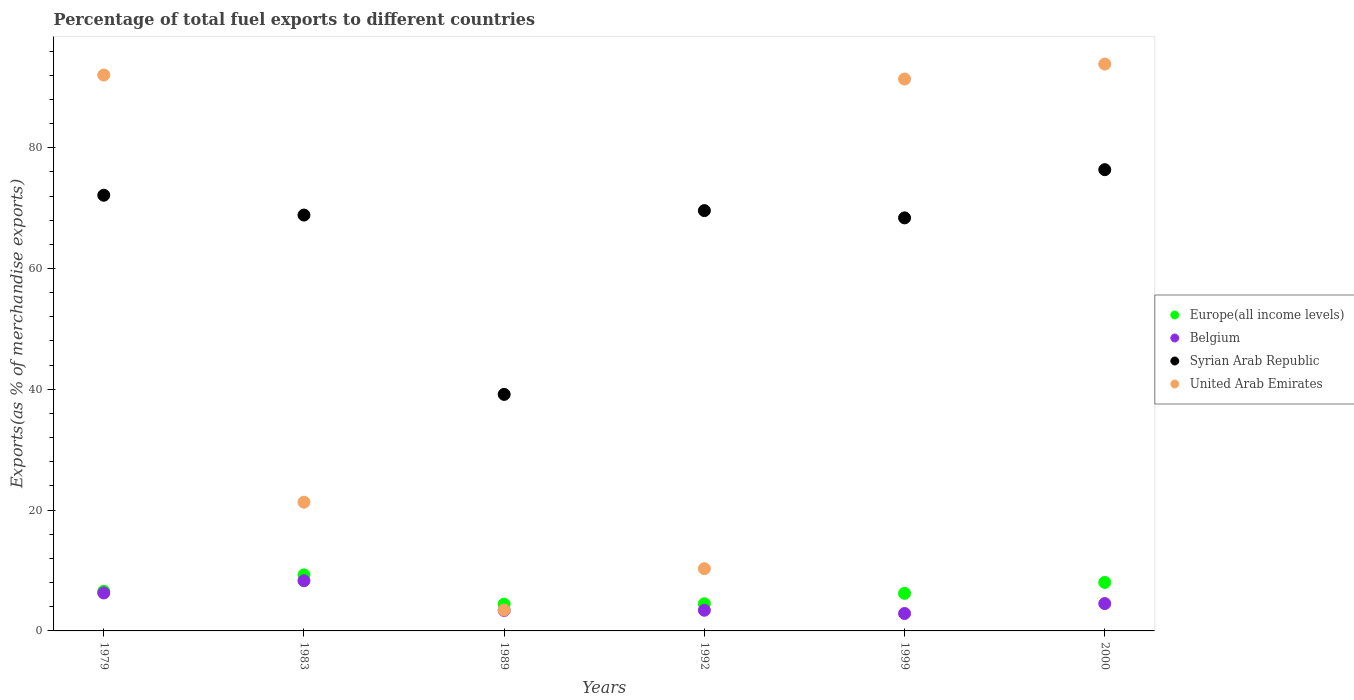Is the number of dotlines equal to the number of legend labels?
Give a very brief answer. Yes. What is the percentage of exports to different countries in Belgium in 2000?
Offer a very short reply. 4.53. Across all years, what is the maximum percentage of exports to different countries in Europe(all income levels)?
Offer a very short reply. 9.28. Across all years, what is the minimum percentage of exports to different countries in United Arab Emirates?
Give a very brief answer. 3.46. What is the total percentage of exports to different countries in Europe(all income levels) in the graph?
Offer a terse response. 39.02. What is the difference between the percentage of exports to different countries in United Arab Emirates in 1989 and that in 1992?
Your response must be concise. -6.85. What is the difference between the percentage of exports to different countries in Syrian Arab Republic in 1989 and the percentage of exports to different countries in Belgium in 2000?
Offer a very short reply. 34.63. What is the average percentage of exports to different countries in Europe(all income levels) per year?
Your answer should be very brief. 6.5. In the year 1983, what is the difference between the percentage of exports to different countries in Europe(all income levels) and percentage of exports to different countries in Belgium?
Offer a very short reply. 0.97. What is the ratio of the percentage of exports to different countries in Europe(all income levels) in 1992 to that in 1999?
Your answer should be very brief. 0.72. Is the percentage of exports to different countries in United Arab Emirates in 1992 less than that in 1999?
Give a very brief answer. Yes. What is the difference between the highest and the second highest percentage of exports to different countries in United Arab Emirates?
Provide a short and direct response. 1.82. What is the difference between the highest and the lowest percentage of exports to different countries in United Arab Emirates?
Your answer should be compact. 90.39. Is the sum of the percentage of exports to different countries in Syrian Arab Republic in 1979 and 1999 greater than the maximum percentage of exports to different countries in Europe(all income levels) across all years?
Make the answer very short. Yes. Is it the case that in every year, the sum of the percentage of exports to different countries in United Arab Emirates and percentage of exports to different countries in Europe(all income levels)  is greater than the percentage of exports to different countries in Belgium?
Offer a terse response. Yes. Is the percentage of exports to different countries in Belgium strictly less than the percentage of exports to different countries in Syrian Arab Republic over the years?
Keep it short and to the point. Yes. What is the difference between two consecutive major ticks on the Y-axis?
Offer a terse response. 20. Does the graph contain any zero values?
Your answer should be very brief. No. Where does the legend appear in the graph?
Your response must be concise. Center right. How many legend labels are there?
Ensure brevity in your answer.  4. How are the legend labels stacked?
Your answer should be compact. Vertical. What is the title of the graph?
Keep it short and to the point. Percentage of total fuel exports to different countries. What is the label or title of the Y-axis?
Make the answer very short. Exports(as % of merchandise exports). What is the Exports(as % of merchandise exports) in Europe(all income levels) in 1979?
Your answer should be very brief. 6.56. What is the Exports(as % of merchandise exports) of Belgium in 1979?
Offer a terse response. 6.29. What is the Exports(as % of merchandise exports) in Syrian Arab Republic in 1979?
Provide a short and direct response. 72.13. What is the Exports(as % of merchandise exports) of United Arab Emirates in 1979?
Offer a terse response. 92.03. What is the Exports(as % of merchandise exports) in Europe(all income levels) in 1983?
Provide a short and direct response. 9.28. What is the Exports(as % of merchandise exports) in Belgium in 1983?
Offer a terse response. 8.31. What is the Exports(as % of merchandise exports) of Syrian Arab Republic in 1983?
Your response must be concise. 68.85. What is the Exports(as % of merchandise exports) of United Arab Emirates in 1983?
Give a very brief answer. 21.31. What is the Exports(as % of merchandise exports) of Europe(all income levels) in 1989?
Your response must be concise. 4.44. What is the Exports(as % of merchandise exports) in Belgium in 1989?
Your response must be concise. 3.39. What is the Exports(as % of merchandise exports) of Syrian Arab Republic in 1989?
Give a very brief answer. 39.16. What is the Exports(as % of merchandise exports) of United Arab Emirates in 1989?
Your answer should be very brief. 3.46. What is the Exports(as % of merchandise exports) in Europe(all income levels) in 1992?
Provide a succinct answer. 4.5. What is the Exports(as % of merchandise exports) in Belgium in 1992?
Your response must be concise. 3.42. What is the Exports(as % of merchandise exports) of Syrian Arab Republic in 1992?
Keep it short and to the point. 69.59. What is the Exports(as % of merchandise exports) of United Arab Emirates in 1992?
Offer a very short reply. 10.3. What is the Exports(as % of merchandise exports) of Europe(all income levels) in 1999?
Your response must be concise. 6.22. What is the Exports(as % of merchandise exports) in Belgium in 1999?
Your answer should be very brief. 2.89. What is the Exports(as % of merchandise exports) in Syrian Arab Republic in 1999?
Keep it short and to the point. 68.38. What is the Exports(as % of merchandise exports) of United Arab Emirates in 1999?
Your response must be concise. 91.37. What is the Exports(as % of merchandise exports) in Europe(all income levels) in 2000?
Your response must be concise. 8.03. What is the Exports(as % of merchandise exports) in Belgium in 2000?
Provide a short and direct response. 4.53. What is the Exports(as % of merchandise exports) in Syrian Arab Republic in 2000?
Your answer should be compact. 76.36. What is the Exports(as % of merchandise exports) in United Arab Emirates in 2000?
Your response must be concise. 93.85. Across all years, what is the maximum Exports(as % of merchandise exports) of Europe(all income levels)?
Provide a short and direct response. 9.28. Across all years, what is the maximum Exports(as % of merchandise exports) of Belgium?
Your answer should be very brief. 8.31. Across all years, what is the maximum Exports(as % of merchandise exports) of Syrian Arab Republic?
Make the answer very short. 76.36. Across all years, what is the maximum Exports(as % of merchandise exports) of United Arab Emirates?
Give a very brief answer. 93.85. Across all years, what is the minimum Exports(as % of merchandise exports) in Europe(all income levels)?
Your response must be concise. 4.44. Across all years, what is the minimum Exports(as % of merchandise exports) of Belgium?
Your answer should be very brief. 2.89. Across all years, what is the minimum Exports(as % of merchandise exports) in Syrian Arab Republic?
Offer a very short reply. 39.16. Across all years, what is the minimum Exports(as % of merchandise exports) of United Arab Emirates?
Your response must be concise. 3.46. What is the total Exports(as % of merchandise exports) in Europe(all income levels) in the graph?
Ensure brevity in your answer.  39.02. What is the total Exports(as % of merchandise exports) of Belgium in the graph?
Offer a terse response. 28.82. What is the total Exports(as % of merchandise exports) of Syrian Arab Republic in the graph?
Offer a very short reply. 394.47. What is the total Exports(as % of merchandise exports) of United Arab Emirates in the graph?
Provide a short and direct response. 312.32. What is the difference between the Exports(as % of merchandise exports) in Europe(all income levels) in 1979 and that in 1983?
Offer a terse response. -2.72. What is the difference between the Exports(as % of merchandise exports) in Belgium in 1979 and that in 1983?
Offer a terse response. -2.02. What is the difference between the Exports(as % of merchandise exports) in Syrian Arab Republic in 1979 and that in 1983?
Make the answer very short. 3.28. What is the difference between the Exports(as % of merchandise exports) of United Arab Emirates in 1979 and that in 1983?
Make the answer very short. 70.72. What is the difference between the Exports(as % of merchandise exports) of Europe(all income levels) in 1979 and that in 1989?
Make the answer very short. 2.13. What is the difference between the Exports(as % of merchandise exports) of Belgium in 1979 and that in 1989?
Ensure brevity in your answer.  2.9. What is the difference between the Exports(as % of merchandise exports) in Syrian Arab Republic in 1979 and that in 1989?
Offer a very short reply. 32.97. What is the difference between the Exports(as % of merchandise exports) in United Arab Emirates in 1979 and that in 1989?
Provide a short and direct response. 88.57. What is the difference between the Exports(as % of merchandise exports) in Europe(all income levels) in 1979 and that in 1992?
Provide a short and direct response. 2.06. What is the difference between the Exports(as % of merchandise exports) of Belgium in 1979 and that in 1992?
Keep it short and to the point. 2.86. What is the difference between the Exports(as % of merchandise exports) of Syrian Arab Republic in 1979 and that in 1992?
Provide a succinct answer. 2.54. What is the difference between the Exports(as % of merchandise exports) in United Arab Emirates in 1979 and that in 1992?
Your response must be concise. 81.72. What is the difference between the Exports(as % of merchandise exports) in Europe(all income levels) in 1979 and that in 1999?
Offer a very short reply. 0.34. What is the difference between the Exports(as % of merchandise exports) in Belgium in 1979 and that in 1999?
Ensure brevity in your answer.  3.4. What is the difference between the Exports(as % of merchandise exports) in Syrian Arab Republic in 1979 and that in 1999?
Your answer should be compact. 3.75. What is the difference between the Exports(as % of merchandise exports) in United Arab Emirates in 1979 and that in 1999?
Keep it short and to the point. 0.66. What is the difference between the Exports(as % of merchandise exports) of Europe(all income levels) in 1979 and that in 2000?
Provide a succinct answer. -1.47. What is the difference between the Exports(as % of merchandise exports) of Belgium in 1979 and that in 2000?
Your response must be concise. 1.76. What is the difference between the Exports(as % of merchandise exports) of Syrian Arab Republic in 1979 and that in 2000?
Your answer should be very brief. -4.23. What is the difference between the Exports(as % of merchandise exports) in United Arab Emirates in 1979 and that in 2000?
Make the answer very short. -1.82. What is the difference between the Exports(as % of merchandise exports) of Europe(all income levels) in 1983 and that in 1989?
Ensure brevity in your answer.  4.84. What is the difference between the Exports(as % of merchandise exports) of Belgium in 1983 and that in 1989?
Provide a succinct answer. 4.92. What is the difference between the Exports(as % of merchandise exports) of Syrian Arab Republic in 1983 and that in 1989?
Provide a succinct answer. 29.69. What is the difference between the Exports(as % of merchandise exports) in United Arab Emirates in 1983 and that in 1989?
Ensure brevity in your answer.  17.85. What is the difference between the Exports(as % of merchandise exports) in Europe(all income levels) in 1983 and that in 1992?
Give a very brief answer. 4.78. What is the difference between the Exports(as % of merchandise exports) in Belgium in 1983 and that in 1992?
Keep it short and to the point. 4.89. What is the difference between the Exports(as % of merchandise exports) in Syrian Arab Republic in 1983 and that in 1992?
Keep it short and to the point. -0.74. What is the difference between the Exports(as % of merchandise exports) in United Arab Emirates in 1983 and that in 1992?
Keep it short and to the point. 11.01. What is the difference between the Exports(as % of merchandise exports) in Europe(all income levels) in 1983 and that in 1999?
Provide a succinct answer. 3.06. What is the difference between the Exports(as % of merchandise exports) in Belgium in 1983 and that in 1999?
Provide a short and direct response. 5.42. What is the difference between the Exports(as % of merchandise exports) of Syrian Arab Republic in 1983 and that in 1999?
Keep it short and to the point. 0.47. What is the difference between the Exports(as % of merchandise exports) of United Arab Emirates in 1983 and that in 1999?
Offer a very short reply. -70.06. What is the difference between the Exports(as % of merchandise exports) in Europe(all income levels) in 1983 and that in 2000?
Give a very brief answer. 1.25. What is the difference between the Exports(as % of merchandise exports) in Belgium in 1983 and that in 2000?
Your answer should be compact. 3.78. What is the difference between the Exports(as % of merchandise exports) of Syrian Arab Republic in 1983 and that in 2000?
Make the answer very short. -7.51. What is the difference between the Exports(as % of merchandise exports) in United Arab Emirates in 1983 and that in 2000?
Ensure brevity in your answer.  -72.54. What is the difference between the Exports(as % of merchandise exports) of Europe(all income levels) in 1989 and that in 1992?
Ensure brevity in your answer.  -0.06. What is the difference between the Exports(as % of merchandise exports) in Belgium in 1989 and that in 1992?
Offer a very short reply. -0.03. What is the difference between the Exports(as % of merchandise exports) in Syrian Arab Republic in 1989 and that in 1992?
Make the answer very short. -30.43. What is the difference between the Exports(as % of merchandise exports) of United Arab Emirates in 1989 and that in 1992?
Ensure brevity in your answer.  -6.85. What is the difference between the Exports(as % of merchandise exports) in Europe(all income levels) in 1989 and that in 1999?
Make the answer very short. -1.78. What is the difference between the Exports(as % of merchandise exports) of Belgium in 1989 and that in 1999?
Keep it short and to the point. 0.5. What is the difference between the Exports(as % of merchandise exports) of Syrian Arab Republic in 1989 and that in 1999?
Your response must be concise. -29.22. What is the difference between the Exports(as % of merchandise exports) of United Arab Emirates in 1989 and that in 1999?
Make the answer very short. -87.91. What is the difference between the Exports(as % of merchandise exports) in Europe(all income levels) in 1989 and that in 2000?
Offer a very short reply. -3.59. What is the difference between the Exports(as % of merchandise exports) in Belgium in 1989 and that in 2000?
Make the answer very short. -1.14. What is the difference between the Exports(as % of merchandise exports) in Syrian Arab Republic in 1989 and that in 2000?
Provide a succinct answer. -37.2. What is the difference between the Exports(as % of merchandise exports) in United Arab Emirates in 1989 and that in 2000?
Offer a very short reply. -90.39. What is the difference between the Exports(as % of merchandise exports) of Europe(all income levels) in 1992 and that in 1999?
Provide a short and direct response. -1.72. What is the difference between the Exports(as % of merchandise exports) in Belgium in 1992 and that in 1999?
Offer a terse response. 0.54. What is the difference between the Exports(as % of merchandise exports) of Syrian Arab Republic in 1992 and that in 1999?
Your response must be concise. 1.2. What is the difference between the Exports(as % of merchandise exports) in United Arab Emirates in 1992 and that in 1999?
Provide a short and direct response. -81.06. What is the difference between the Exports(as % of merchandise exports) in Europe(all income levels) in 1992 and that in 2000?
Your answer should be very brief. -3.53. What is the difference between the Exports(as % of merchandise exports) of Belgium in 1992 and that in 2000?
Provide a succinct answer. -1.11. What is the difference between the Exports(as % of merchandise exports) in Syrian Arab Republic in 1992 and that in 2000?
Give a very brief answer. -6.78. What is the difference between the Exports(as % of merchandise exports) of United Arab Emirates in 1992 and that in 2000?
Ensure brevity in your answer.  -83.54. What is the difference between the Exports(as % of merchandise exports) in Europe(all income levels) in 1999 and that in 2000?
Your answer should be very brief. -1.81. What is the difference between the Exports(as % of merchandise exports) of Belgium in 1999 and that in 2000?
Make the answer very short. -1.64. What is the difference between the Exports(as % of merchandise exports) of Syrian Arab Republic in 1999 and that in 2000?
Ensure brevity in your answer.  -7.98. What is the difference between the Exports(as % of merchandise exports) of United Arab Emirates in 1999 and that in 2000?
Offer a very short reply. -2.48. What is the difference between the Exports(as % of merchandise exports) of Europe(all income levels) in 1979 and the Exports(as % of merchandise exports) of Belgium in 1983?
Your response must be concise. -1.75. What is the difference between the Exports(as % of merchandise exports) in Europe(all income levels) in 1979 and the Exports(as % of merchandise exports) in Syrian Arab Republic in 1983?
Give a very brief answer. -62.29. What is the difference between the Exports(as % of merchandise exports) of Europe(all income levels) in 1979 and the Exports(as % of merchandise exports) of United Arab Emirates in 1983?
Your answer should be compact. -14.75. What is the difference between the Exports(as % of merchandise exports) in Belgium in 1979 and the Exports(as % of merchandise exports) in Syrian Arab Republic in 1983?
Provide a succinct answer. -62.56. What is the difference between the Exports(as % of merchandise exports) of Belgium in 1979 and the Exports(as % of merchandise exports) of United Arab Emirates in 1983?
Ensure brevity in your answer.  -15.02. What is the difference between the Exports(as % of merchandise exports) of Syrian Arab Republic in 1979 and the Exports(as % of merchandise exports) of United Arab Emirates in 1983?
Offer a very short reply. 50.82. What is the difference between the Exports(as % of merchandise exports) of Europe(all income levels) in 1979 and the Exports(as % of merchandise exports) of Belgium in 1989?
Ensure brevity in your answer.  3.17. What is the difference between the Exports(as % of merchandise exports) in Europe(all income levels) in 1979 and the Exports(as % of merchandise exports) in Syrian Arab Republic in 1989?
Keep it short and to the point. -32.6. What is the difference between the Exports(as % of merchandise exports) of Europe(all income levels) in 1979 and the Exports(as % of merchandise exports) of United Arab Emirates in 1989?
Your response must be concise. 3.1. What is the difference between the Exports(as % of merchandise exports) in Belgium in 1979 and the Exports(as % of merchandise exports) in Syrian Arab Republic in 1989?
Provide a short and direct response. -32.87. What is the difference between the Exports(as % of merchandise exports) of Belgium in 1979 and the Exports(as % of merchandise exports) of United Arab Emirates in 1989?
Offer a terse response. 2.83. What is the difference between the Exports(as % of merchandise exports) in Syrian Arab Republic in 1979 and the Exports(as % of merchandise exports) in United Arab Emirates in 1989?
Your response must be concise. 68.67. What is the difference between the Exports(as % of merchandise exports) in Europe(all income levels) in 1979 and the Exports(as % of merchandise exports) in Belgium in 1992?
Provide a short and direct response. 3.14. What is the difference between the Exports(as % of merchandise exports) of Europe(all income levels) in 1979 and the Exports(as % of merchandise exports) of Syrian Arab Republic in 1992?
Provide a succinct answer. -63.03. What is the difference between the Exports(as % of merchandise exports) of Europe(all income levels) in 1979 and the Exports(as % of merchandise exports) of United Arab Emirates in 1992?
Provide a succinct answer. -3.74. What is the difference between the Exports(as % of merchandise exports) of Belgium in 1979 and the Exports(as % of merchandise exports) of Syrian Arab Republic in 1992?
Give a very brief answer. -63.3. What is the difference between the Exports(as % of merchandise exports) of Belgium in 1979 and the Exports(as % of merchandise exports) of United Arab Emirates in 1992?
Keep it short and to the point. -4.02. What is the difference between the Exports(as % of merchandise exports) in Syrian Arab Republic in 1979 and the Exports(as % of merchandise exports) in United Arab Emirates in 1992?
Your answer should be very brief. 61.83. What is the difference between the Exports(as % of merchandise exports) of Europe(all income levels) in 1979 and the Exports(as % of merchandise exports) of Belgium in 1999?
Provide a short and direct response. 3.67. What is the difference between the Exports(as % of merchandise exports) of Europe(all income levels) in 1979 and the Exports(as % of merchandise exports) of Syrian Arab Republic in 1999?
Make the answer very short. -61.82. What is the difference between the Exports(as % of merchandise exports) of Europe(all income levels) in 1979 and the Exports(as % of merchandise exports) of United Arab Emirates in 1999?
Provide a short and direct response. -84.81. What is the difference between the Exports(as % of merchandise exports) in Belgium in 1979 and the Exports(as % of merchandise exports) in Syrian Arab Republic in 1999?
Provide a succinct answer. -62.09. What is the difference between the Exports(as % of merchandise exports) in Belgium in 1979 and the Exports(as % of merchandise exports) in United Arab Emirates in 1999?
Offer a terse response. -85.08. What is the difference between the Exports(as % of merchandise exports) of Syrian Arab Republic in 1979 and the Exports(as % of merchandise exports) of United Arab Emirates in 1999?
Ensure brevity in your answer.  -19.24. What is the difference between the Exports(as % of merchandise exports) of Europe(all income levels) in 1979 and the Exports(as % of merchandise exports) of Belgium in 2000?
Make the answer very short. 2.03. What is the difference between the Exports(as % of merchandise exports) of Europe(all income levels) in 1979 and the Exports(as % of merchandise exports) of Syrian Arab Republic in 2000?
Provide a succinct answer. -69.8. What is the difference between the Exports(as % of merchandise exports) in Europe(all income levels) in 1979 and the Exports(as % of merchandise exports) in United Arab Emirates in 2000?
Provide a succinct answer. -87.29. What is the difference between the Exports(as % of merchandise exports) in Belgium in 1979 and the Exports(as % of merchandise exports) in Syrian Arab Republic in 2000?
Keep it short and to the point. -70.07. What is the difference between the Exports(as % of merchandise exports) of Belgium in 1979 and the Exports(as % of merchandise exports) of United Arab Emirates in 2000?
Offer a terse response. -87.56. What is the difference between the Exports(as % of merchandise exports) in Syrian Arab Republic in 1979 and the Exports(as % of merchandise exports) in United Arab Emirates in 2000?
Make the answer very short. -21.72. What is the difference between the Exports(as % of merchandise exports) of Europe(all income levels) in 1983 and the Exports(as % of merchandise exports) of Belgium in 1989?
Provide a succinct answer. 5.89. What is the difference between the Exports(as % of merchandise exports) in Europe(all income levels) in 1983 and the Exports(as % of merchandise exports) in Syrian Arab Republic in 1989?
Ensure brevity in your answer.  -29.88. What is the difference between the Exports(as % of merchandise exports) in Europe(all income levels) in 1983 and the Exports(as % of merchandise exports) in United Arab Emirates in 1989?
Provide a succinct answer. 5.82. What is the difference between the Exports(as % of merchandise exports) of Belgium in 1983 and the Exports(as % of merchandise exports) of Syrian Arab Republic in 1989?
Your response must be concise. -30.85. What is the difference between the Exports(as % of merchandise exports) of Belgium in 1983 and the Exports(as % of merchandise exports) of United Arab Emirates in 1989?
Provide a short and direct response. 4.85. What is the difference between the Exports(as % of merchandise exports) in Syrian Arab Republic in 1983 and the Exports(as % of merchandise exports) in United Arab Emirates in 1989?
Make the answer very short. 65.39. What is the difference between the Exports(as % of merchandise exports) in Europe(all income levels) in 1983 and the Exports(as % of merchandise exports) in Belgium in 1992?
Your answer should be very brief. 5.86. What is the difference between the Exports(as % of merchandise exports) of Europe(all income levels) in 1983 and the Exports(as % of merchandise exports) of Syrian Arab Republic in 1992?
Provide a short and direct response. -60.31. What is the difference between the Exports(as % of merchandise exports) in Europe(all income levels) in 1983 and the Exports(as % of merchandise exports) in United Arab Emirates in 1992?
Make the answer very short. -1.03. What is the difference between the Exports(as % of merchandise exports) in Belgium in 1983 and the Exports(as % of merchandise exports) in Syrian Arab Republic in 1992?
Your answer should be compact. -61.28. What is the difference between the Exports(as % of merchandise exports) in Belgium in 1983 and the Exports(as % of merchandise exports) in United Arab Emirates in 1992?
Offer a terse response. -2. What is the difference between the Exports(as % of merchandise exports) in Syrian Arab Republic in 1983 and the Exports(as % of merchandise exports) in United Arab Emirates in 1992?
Your answer should be compact. 58.54. What is the difference between the Exports(as % of merchandise exports) in Europe(all income levels) in 1983 and the Exports(as % of merchandise exports) in Belgium in 1999?
Ensure brevity in your answer.  6.39. What is the difference between the Exports(as % of merchandise exports) of Europe(all income levels) in 1983 and the Exports(as % of merchandise exports) of Syrian Arab Republic in 1999?
Give a very brief answer. -59.1. What is the difference between the Exports(as % of merchandise exports) of Europe(all income levels) in 1983 and the Exports(as % of merchandise exports) of United Arab Emirates in 1999?
Your response must be concise. -82.09. What is the difference between the Exports(as % of merchandise exports) of Belgium in 1983 and the Exports(as % of merchandise exports) of Syrian Arab Republic in 1999?
Give a very brief answer. -60.07. What is the difference between the Exports(as % of merchandise exports) of Belgium in 1983 and the Exports(as % of merchandise exports) of United Arab Emirates in 1999?
Provide a short and direct response. -83.06. What is the difference between the Exports(as % of merchandise exports) in Syrian Arab Republic in 1983 and the Exports(as % of merchandise exports) in United Arab Emirates in 1999?
Keep it short and to the point. -22.52. What is the difference between the Exports(as % of merchandise exports) of Europe(all income levels) in 1983 and the Exports(as % of merchandise exports) of Belgium in 2000?
Make the answer very short. 4.75. What is the difference between the Exports(as % of merchandise exports) in Europe(all income levels) in 1983 and the Exports(as % of merchandise exports) in Syrian Arab Republic in 2000?
Your response must be concise. -67.08. What is the difference between the Exports(as % of merchandise exports) in Europe(all income levels) in 1983 and the Exports(as % of merchandise exports) in United Arab Emirates in 2000?
Your answer should be very brief. -84.57. What is the difference between the Exports(as % of merchandise exports) in Belgium in 1983 and the Exports(as % of merchandise exports) in Syrian Arab Republic in 2000?
Your answer should be compact. -68.05. What is the difference between the Exports(as % of merchandise exports) in Belgium in 1983 and the Exports(as % of merchandise exports) in United Arab Emirates in 2000?
Offer a terse response. -85.54. What is the difference between the Exports(as % of merchandise exports) in Syrian Arab Republic in 1983 and the Exports(as % of merchandise exports) in United Arab Emirates in 2000?
Your answer should be very brief. -25. What is the difference between the Exports(as % of merchandise exports) of Europe(all income levels) in 1989 and the Exports(as % of merchandise exports) of Belgium in 1992?
Offer a terse response. 1.01. What is the difference between the Exports(as % of merchandise exports) in Europe(all income levels) in 1989 and the Exports(as % of merchandise exports) in Syrian Arab Republic in 1992?
Offer a terse response. -65.15. What is the difference between the Exports(as % of merchandise exports) of Europe(all income levels) in 1989 and the Exports(as % of merchandise exports) of United Arab Emirates in 1992?
Your answer should be compact. -5.87. What is the difference between the Exports(as % of merchandise exports) in Belgium in 1989 and the Exports(as % of merchandise exports) in Syrian Arab Republic in 1992?
Offer a terse response. -66.2. What is the difference between the Exports(as % of merchandise exports) in Belgium in 1989 and the Exports(as % of merchandise exports) in United Arab Emirates in 1992?
Give a very brief answer. -6.92. What is the difference between the Exports(as % of merchandise exports) of Syrian Arab Republic in 1989 and the Exports(as % of merchandise exports) of United Arab Emirates in 1992?
Ensure brevity in your answer.  28.86. What is the difference between the Exports(as % of merchandise exports) in Europe(all income levels) in 1989 and the Exports(as % of merchandise exports) in Belgium in 1999?
Keep it short and to the point. 1.55. What is the difference between the Exports(as % of merchandise exports) in Europe(all income levels) in 1989 and the Exports(as % of merchandise exports) in Syrian Arab Republic in 1999?
Offer a very short reply. -63.95. What is the difference between the Exports(as % of merchandise exports) of Europe(all income levels) in 1989 and the Exports(as % of merchandise exports) of United Arab Emirates in 1999?
Offer a very short reply. -86.93. What is the difference between the Exports(as % of merchandise exports) of Belgium in 1989 and the Exports(as % of merchandise exports) of Syrian Arab Republic in 1999?
Ensure brevity in your answer.  -64.99. What is the difference between the Exports(as % of merchandise exports) in Belgium in 1989 and the Exports(as % of merchandise exports) in United Arab Emirates in 1999?
Make the answer very short. -87.98. What is the difference between the Exports(as % of merchandise exports) of Syrian Arab Republic in 1989 and the Exports(as % of merchandise exports) of United Arab Emirates in 1999?
Give a very brief answer. -52.21. What is the difference between the Exports(as % of merchandise exports) in Europe(all income levels) in 1989 and the Exports(as % of merchandise exports) in Belgium in 2000?
Provide a short and direct response. -0.09. What is the difference between the Exports(as % of merchandise exports) in Europe(all income levels) in 1989 and the Exports(as % of merchandise exports) in Syrian Arab Republic in 2000?
Your answer should be compact. -71.93. What is the difference between the Exports(as % of merchandise exports) of Europe(all income levels) in 1989 and the Exports(as % of merchandise exports) of United Arab Emirates in 2000?
Offer a very short reply. -89.41. What is the difference between the Exports(as % of merchandise exports) in Belgium in 1989 and the Exports(as % of merchandise exports) in Syrian Arab Republic in 2000?
Your answer should be very brief. -72.97. What is the difference between the Exports(as % of merchandise exports) of Belgium in 1989 and the Exports(as % of merchandise exports) of United Arab Emirates in 2000?
Provide a succinct answer. -90.46. What is the difference between the Exports(as % of merchandise exports) in Syrian Arab Republic in 1989 and the Exports(as % of merchandise exports) in United Arab Emirates in 2000?
Your answer should be compact. -54.69. What is the difference between the Exports(as % of merchandise exports) in Europe(all income levels) in 1992 and the Exports(as % of merchandise exports) in Belgium in 1999?
Give a very brief answer. 1.61. What is the difference between the Exports(as % of merchandise exports) of Europe(all income levels) in 1992 and the Exports(as % of merchandise exports) of Syrian Arab Republic in 1999?
Your response must be concise. -63.89. What is the difference between the Exports(as % of merchandise exports) of Europe(all income levels) in 1992 and the Exports(as % of merchandise exports) of United Arab Emirates in 1999?
Ensure brevity in your answer.  -86.87. What is the difference between the Exports(as % of merchandise exports) in Belgium in 1992 and the Exports(as % of merchandise exports) in Syrian Arab Republic in 1999?
Ensure brevity in your answer.  -64.96. What is the difference between the Exports(as % of merchandise exports) of Belgium in 1992 and the Exports(as % of merchandise exports) of United Arab Emirates in 1999?
Keep it short and to the point. -87.95. What is the difference between the Exports(as % of merchandise exports) of Syrian Arab Republic in 1992 and the Exports(as % of merchandise exports) of United Arab Emirates in 1999?
Your answer should be very brief. -21.78. What is the difference between the Exports(as % of merchandise exports) of Europe(all income levels) in 1992 and the Exports(as % of merchandise exports) of Belgium in 2000?
Give a very brief answer. -0.03. What is the difference between the Exports(as % of merchandise exports) in Europe(all income levels) in 1992 and the Exports(as % of merchandise exports) in Syrian Arab Republic in 2000?
Ensure brevity in your answer.  -71.87. What is the difference between the Exports(as % of merchandise exports) of Europe(all income levels) in 1992 and the Exports(as % of merchandise exports) of United Arab Emirates in 2000?
Provide a short and direct response. -89.35. What is the difference between the Exports(as % of merchandise exports) of Belgium in 1992 and the Exports(as % of merchandise exports) of Syrian Arab Republic in 2000?
Your answer should be compact. -72.94. What is the difference between the Exports(as % of merchandise exports) in Belgium in 1992 and the Exports(as % of merchandise exports) in United Arab Emirates in 2000?
Your response must be concise. -90.43. What is the difference between the Exports(as % of merchandise exports) in Syrian Arab Republic in 1992 and the Exports(as % of merchandise exports) in United Arab Emirates in 2000?
Your answer should be compact. -24.26. What is the difference between the Exports(as % of merchandise exports) in Europe(all income levels) in 1999 and the Exports(as % of merchandise exports) in Belgium in 2000?
Keep it short and to the point. 1.69. What is the difference between the Exports(as % of merchandise exports) in Europe(all income levels) in 1999 and the Exports(as % of merchandise exports) in Syrian Arab Republic in 2000?
Provide a succinct answer. -70.14. What is the difference between the Exports(as % of merchandise exports) in Europe(all income levels) in 1999 and the Exports(as % of merchandise exports) in United Arab Emirates in 2000?
Offer a terse response. -87.63. What is the difference between the Exports(as % of merchandise exports) of Belgium in 1999 and the Exports(as % of merchandise exports) of Syrian Arab Republic in 2000?
Keep it short and to the point. -73.48. What is the difference between the Exports(as % of merchandise exports) of Belgium in 1999 and the Exports(as % of merchandise exports) of United Arab Emirates in 2000?
Your answer should be very brief. -90.96. What is the difference between the Exports(as % of merchandise exports) in Syrian Arab Republic in 1999 and the Exports(as % of merchandise exports) in United Arab Emirates in 2000?
Provide a succinct answer. -25.47. What is the average Exports(as % of merchandise exports) of Europe(all income levels) per year?
Your answer should be very brief. 6.5. What is the average Exports(as % of merchandise exports) of Belgium per year?
Offer a very short reply. 4.8. What is the average Exports(as % of merchandise exports) in Syrian Arab Republic per year?
Give a very brief answer. 65.74. What is the average Exports(as % of merchandise exports) of United Arab Emirates per year?
Your response must be concise. 52.05. In the year 1979, what is the difference between the Exports(as % of merchandise exports) in Europe(all income levels) and Exports(as % of merchandise exports) in Belgium?
Make the answer very short. 0.27. In the year 1979, what is the difference between the Exports(as % of merchandise exports) in Europe(all income levels) and Exports(as % of merchandise exports) in Syrian Arab Republic?
Provide a short and direct response. -65.57. In the year 1979, what is the difference between the Exports(as % of merchandise exports) of Europe(all income levels) and Exports(as % of merchandise exports) of United Arab Emirates?
Give a very brief answer. -85.47. In the year 1979, what is the difference between the Exports(as % of merchandise exports) in Belgium and Exports(as % of merchandise exports) in Syrian Arab Republic?
Keep it short and to the point. -65.84. In the year 1979, what is the difference between the Exports(as % of merchandise exports) in Belgium and Exports(as % of merchandise exports) in United Arab Emirates?
Keep it short and to the point. -85.74. In the year 1979, what is the difference between the Exports(as % of merchandise exports) in Syrian Arab Republic and Exports(as % of merchandise exports) in United Arab Emirates?
Provide a short and direct response. -19.9. In the year 1983, what is the difference between the Exports(as % of merchandise exports) in Europe(all income levels) and Exports(as % of merchandise exports) in Belgium?
Your response must be concise. 0.97. In the year 1983, what is the difference between the Exports(as % of merchandise exports) of Europe(all income levels) and Exports(as % of merchandise exports) of Syrian Arab Republic?
Your answer should be compact. -59.57. In the year 1983, what is the difference between the Exports(as % of merchandise exports) in Europe(all income levels) and Exports(as % of merchandise exports) in United Arab Emirates?
Offer a very short reply. -12.03. In the year 1983, what is the difference between the Exports(as % of merchandise exports) in Belgium and Exports(as % of merchandise exports) in Syrian Arab Republic?
Your response must be concise. -60.54. In the year 1983, what is the difference between the Exports(as % of merchandise exports) of Belgium and Exports(as % of merchandise exports) of United Arab Emirates?
Your answer should be very brief. -13. In the year 1983, what is the difference between the Exports(as % of merchandise exports) in Syrian Arab Republic and Exports(as % of merchandise exports) in United Arab Emirates?
Provide a short and direct response. 47.54. In the year 1989, what is the difference between the Exports(as % of merchandise exports) in Europe(all income levels) and Exports(as % of merchandise exports) in Belgium?
Provide a succinct answer. 1.05. In the year 1989, what is the difference between the Exports(as % of merchandise exports) in Europe(all income levels) and Exports(as % of merchandise exports) in Syrian Arab Republic?
Offer a very short reply. -34.72. In the year 1989, what is the difference between the Exports(as % of merchandise exports) in Europe(all income levels) and Exports(as % of merchandise exports) in United Arab Emirates?
Keep it short and to the point. 0.98. In the year 1989, what is the difference between the Exports(as % of merchandise exports) of Belgium and Exports(as % of merchandise exports) of Syrian Arab Republic?
Your answer should be very brief. -35.77. In the year 1989, what is the difference between the Exports(as % of merchandise exports) of Belgium and Exports(as % of merchandise exports) of United Arab Emirates?
Offer a terse response. -0.07. In the year 1989, what is the difference between the Exports(as % of merchandise exports) in Syrian Arab Republic and Exports(as % of merchandise exports) in United Arab Emirates?
Provide a short and direct response. 35.7. In the year 1992, what is the difference between the Exports(as % of merchandise exports) of Europe(all income levels) and Exports(as % of merchandise exports) of Belgium?
Make the answer very short. 1.07. In the year 1992, what is the difference between the Exports(as % of merchandise exports) of Europe(all income levels) and Exports(as % of merchandise exports) of Syrian Arab Republic?
Your answer should be very brief. -65.09. In the year 1992, what is the difference between the Exports(as % of merchandise exports) of Europe(all income levels) and Exports(as % of merchandise exports) of United Arab Emirates?
Offer a very short reply. -5.81. In the year 1992, what is the difference between the Exports(as % of merchandise exports) in Belgium and Exports(as % of merchandise exports) in Syrian Arab Republic?
Your answer should be very brief. -66.16. In the year 1992, what is the difference between the Exports(as % of merchandise exports) of Belgium and Exports(as % of merchandise exports) of United Arab Emirates?
Provide a short and direct response. -6.88. In the year 1992, what is the difference between the Exports(as % of merchandise exports) of Syrian Arab Republic and Exports(as % of merchandise exports) of United Arab Emirates?
Ensure brevity in your answer.  59.28. In the year 1999, what is the difference between the Exports(as % of merchandise exports) in Europe(all income levels) and Exports(as % of merchandise exports) in Belgium?
Your answer should be compact. 3.33. In the year 1999, what is the difference between the Exports(as % of merchandise exports) of Europe(all income levels) and Exports(as % of merchandise exports) of Syrian Arab Republic?
Offer a terse response. -62.16. In the year 1999, what is the difference between the Exports(as % of merchandise exports) of Europe(all income levels) and Exports(as % of merchandise exports) of United Arab Emirates?
Your answer should be compact. -85.15. In the year 1999, what is the difference between the Exports(as % of merchandise exports) of Belgium and Exports(as % of merchandise exports) of Syrian Arab Republic?
Provide a succinct answer. -65.5. In the year 1999, what is the difference between the Exports(as % of merchandise exports) of Belgium and Exports(as % of merchandise exports) of United Arab Emirates?
Your answer should be very brief. -88.48. In the year 1999, what is the difference between the Exports(as % of merchandise exports) in Syrian Arab Republic and Exports(as % of merchandise exports) in United Arab Emirates?
Offer a very short reply. -22.99. In the year 2000, what is the difference between the Exports(as % of merchandise exports) in Europe(all income levels) and Exports(as % of merchandise exports) in Belgium?
Make the answer very short. 3.5. In the year 2000, what is the difference between the Exports(as % of merchandise exports) of Europe(all income levels) and Exports(as % of merchandise exports) of Syrian Arab Republic?
Offer a terse response. -68.34. In the year 2000, what is the difference between the Exports(as % of merchandise exports) of Europe(all income levels) and Exports(as % of merchandise exports) of United Arab Emirates?
Provide a short and direct response. -85.82. In the year 2000, what is the difference between the Exports(as % of merchandise exports) in Belgium and Exports(as % of merchandise exports) in Syrian Arab Republic?
Provide a succinct answer. -71.83. In the year 2000, what is the difference between the Exports(as % of merchandise exports) of Belgium and Exports(as % of merchandise exports) of United Arab Emirates?
Your response must be concise. -89.32. In the year 2000, what is the difference between the Exports(as % of merchandise exports) in Syrian Arab Republic and Exports(as % of merchandise exports) in United Arab Emirates?
Offer a terse response. -17.49. What is the ratio of the Exports(as % of merchandise exports) of Europe(all income levels) in 1979 to that in 1983?
Give a very brief answer. 0.71. What is the ratio of the Exports(as % of merchandise exports) in Belgium in 1979 to that in 1983?
Make the answer very short. 0.76. What is the ratio of the Exports(as % of merchandise exports) of Syrian Arab Republic in 1979 to that in 1983?
Make the answer very short. 1.05. What is the ratio of the Exports(as % of merchandise exports) of United Arab Emirates in 1979 to that in 1983?
Your response must be concise. 4.32. What is the ratio of the Exports(as % of merchandise exports) in Europe(all income levels) in 1979 to that in 1989?
Your answer should be very brief. 1.48. What is the ratio of the Exports(as % of merchandise exports) in Belgium in 1979 to that in 1989?
Your answer should be compact. 1.86. What is the ratio of the Exports(as % of merchandise exports) of Syrian Arab Republic in 1979 to that in 1989?
Keep it short and to the point. 1.84. What is the ratio of the Exports(as % of merchandise exports) in United Arab Emirates in 1979 to that in 1989?
Make the answer very short. 26.61. What is the ratio of the Exports(as % of merchandise exports) of Europe(all income levels) in 1979 to that in 1992?
Make the answer very short. 1.46. What is the ratio of the Exports(as % of merchandise exports) of Belgium in 1979 to that in 1992?
Give a very brief answer. 1.84. What is the ratio of the Exports(as % of merchandise exports) of Syrian Arab Republic in 1979 to that in 1992?
Provide a short and direct response. 1.04. What is the ratio of the Exports(as % of merchandise exports) of United Arab Emirates in 1979 to that in 1992?
Offer a very short reply. 8.93. What is the ratio of the Exports(as % of merchandise exports) of Europe(all income levels) in 1979 to that in 1999?
Keep it short and to the point. 1.05. What is the ratio of the Exports(as % of merchandise exports) in Belgium in 1979 to that in 1999?
Ensure brevity in your answer.  2.18. What is the ratio of the Exports(as % of merchandise exports) in Syrian Arab Republic in 1979 to that in 1999?
Your response must be concise. 1.05. What is the ratio of the Exports(as % of merchandise exports) in Europe(all income levels) in 1979 to that in 2000?
Provide a short and direct response. 0.82. What is the ratio of the Exports(as % of merchandise exports) in Belgium in 1979 to that in 2000?
Provide a short and direct response. 1.39. What is the ratio of the Exports(as % of merchandise exports) of Syrian Arab Republic in 1979 to that in 2000?
Make the answer very short. 0.94. What is the ratio of the Exports(as % of merchandise exports) in United Arab Emirates in 1979 to that in 2000?
Ensure brevity in your answer.  0.98. What is the ratio of the Exports(as % of merchandise exports) in Europe(all income levels) in 1983 to that in 1989?
Make the answer very short. 2.09. What is the ratio of the Exports(as % of merchandise exports) in Belgium in 1983 to that in 1989?
Your answer should be very brief. 2.45. What is the ratio of the Exports(as % of merchandise exports) in Syrian Arab Republic in 1983 to that in 1989?
Your answer should be compact. 1.76. What is the ratio of the Exports(as % of merchandise exports) in United Arab Emirates in 1983 to that in 1989?
Make the answer very short. 6.16. What is the ratio of the Exports(as % of merchandise exports) of Europe(all income levels) in 1983 to that in 1992?
Give a very brief answer. 2.06. What is the ratio of the Exports(as % of merchandise exports) in Belgium in 1983 to that in 1992?
Ensure brevity in your answer.  2.43. What is the ratio of the Exports(as % of merchandise exports) in Syrian Arab Republic in 1983 to that in 1992?
Provide a short and direct response. 0.99. What is the ratio of the Exports(as % of merchandise exports) of United Arab Emirates in 1983 to that in 1992?
Give a very brief answer. 2.07. What is the ratio of the Exports(as % of merchandise exports) in Europe(all income levels) in 1983 to that in 1999?
Ensure brevity in your answer.  1.49. What is the ratio of the Exports(as % of merchandise exports) in Belgium in 1983 to that in 1999?
Offer a very short reply. 2.88. What is the ratio of the Exports(as % of merchandise exports) of Syrian Arab Republic in 1983 to that in 1999?
Offer a terse response. 1.01. What is the ratio of the Exports(as % of merchandise exports) in United Arab Emirates in 1983 to that in 1999?
Offer a terse response. 0.23. What is the ratio of the Exports(as % of merchandise exports) in Europe(all income levels) in 1983 to that in 2000?
Offer a terse response. 1.16. What is the ratio of the Exports(as % of merchandise exports) of Belgium in 1983 to that in 2000?
Make the answer very short. 1.84. What is the ratio of the Exports(as % of merchandise exports) of Syrian Arab Republic in 1983 to that in 2000?
Offer a very short reply. 0.9. What is the ratio of the Exports(as % of merchandise exports) of United Arab Emirates in 1983 to that in 2000?
Your answer should be very brief. 0.23. What is the ratio of the Exports(as % of merchandise exports) of Europe(all income levels) in 1989 to that in 1992?
Ensure brevity in your answer.  0.99. What is the ratio of the Exports(as % of merchandise exports) in Syrian Arab Republic in 1989 to that in 1992?
Ensure brevity in your answer.  0.56. What is the ratio of the Exports(as % of merchandise exports) of United Arab Emirates in 1989 to that in 1992?
Give a very brief answer. 0.34. What is the ratio of the Exports(as % of merchandise exports) of Europe(all income levels) in 1989 to that in 1999?
Offer a very short reply. 0.71. What is the ratio of the Exports(as % of merchandise exports) in Belgium in 1989 to that in 1999?
Offer a terse response. 1.17. What is the ratio of the Exports(as % of merchandise exports) in Syrian Arab Republic in 1989 to that in 1999?
Give a very brief answer. 0.57. What is the ratio of the Exports(as % of merchandise exports) of United Arab Emirates in 1989 to that in 1999?
Your response must be concise. 0.04. What is the ratio of the Exports(as % of merchandise exports) in Europe(all income levels) in 1989 to that in 2000?
Ensure brevity in your answer.  0.55. What is the ratio of the Exports(as % of merchandise exports) of Belgium in 1989 to that in 2000?
Provide a short and direct response. 0.75. What is the ratio of the Exports(as % of merchandise exports) in Syrian Arab Republic in 1989 to that in 2000?
Offer a terse response. 0.51. What is the ratio of the Exports(as % of merchandise exports) of United Arab Emirates in 1989 to that in 2000?
Ensure brevity in your answer.  0.04. What is the ratio of the Exports(as % of merchandise exports) in Europe(all income levels) in 1992 to that in 1999?
Your answer should be compact. 0.72. What is the ratio of the Exports(as % of merchandise exports) of Belgium in 1992 to that in 1999?
Your answer should be compact. 1.19. What is the ratio of the Exports(as % of merchandise exports) in Syrian Arab Republic in 1992 to that in 1999?
Ensure brevity in your answer.  1.02. What is the ratio of the Exports(as % of merchandise exports) of United Arab Emirates in 1992 to that in 1999?
Your answer should be compact. 0.11. What is the ratio of the Exports(as % of merchandise exports) in Europe(all income levels) in 1992 to that in 2000?
Your answer should be very brief. 0.56. What is the ratio of the Exports(as % of merchandise exports) of Belgium in 1992 to that in 2000?
Your response must be concise. 0.76. What is the ratio of the Exports(as % of merchandise exports) in Syrian Arab Republic in 1992 to that in 2000?
Make the answer very short. 0.91. What is the ratio of the Exports(as % of merchandise exports) in United Arab Emirates in 1992 to that in 2000?
Give a very brief answer. 0.11. What is the ratio of the Exports(as % of merchandise exports) of Europe(all income levels) in 1999 to that in 2000?
Provide a succinct answer. 0.77. What is the ratio of the Exports(as % of merchandise exports) of Belgium in 1999 to that in 2000?
Give a very brief answer. 0.64. What is the ratio of the Exports(as % of merchandise exports) in Syrian Arab Republic in 1999 to that in 2000?
Keep it short and to the point. 0.9. What is the ratio of the Exports(as % of merchandise exports) of United Arab Emirates in 1999 to that in 2000?
Give a very brief answer. 0.97. What is the difference between the highest and the second highest Exports(as % of merchandise exports) in Europe(all income levels)?
Give a very brief answer. 1.25. What is the difference between the highest and the second highest Exports(as % of merchandise exports) of Belgium?
Your answer should be very brief. 2.02. What is the difference between the highest and the second highest Exports(as % of merchandise exports) in Syrian Arab Republic?
Keep it short and to the point. 4.23. What is the difference between the highest and the second highest Exports(as % of merchandise exports) in United Arab Emirates?
Your answer should be very brief. 1.82. What is the difference between the highest and the lowest Exports(as % of merchandise exports) in Europe(all income levels)?
Make the answer very short. 4.84. What is the difference between the highest and the lowest Exports(as % of merchandise exports) of Belgium?
Ensure brevity in your answer.  5.42. What is the difference between the highest and the lowest Exports(as % of merchandise exports) in Syrian Arab Republic?
Keep it short and to the point. 37.2. What is the difference between the highest and the lowest Exports(as % of merchandise exports) in United Arab Emirates?
Your answer should be very brief. 90.39. 